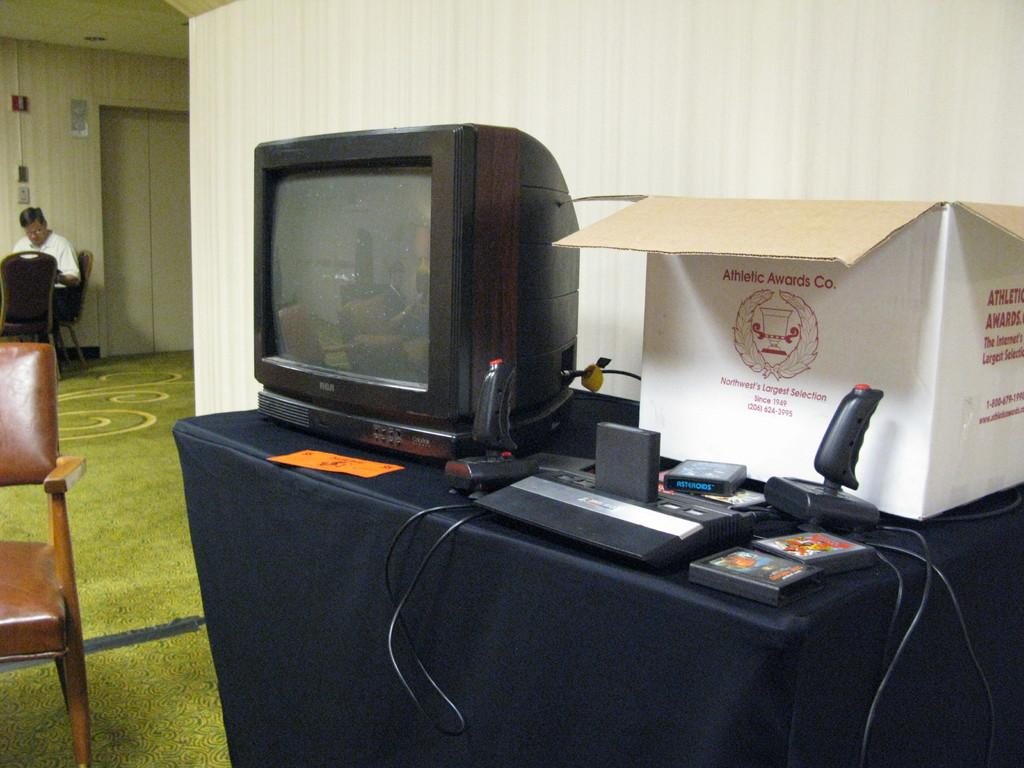<image>
Relay a brief, clear account of the picture shown. An old TV is on a table next to a box that says Athletic Awards Co. 